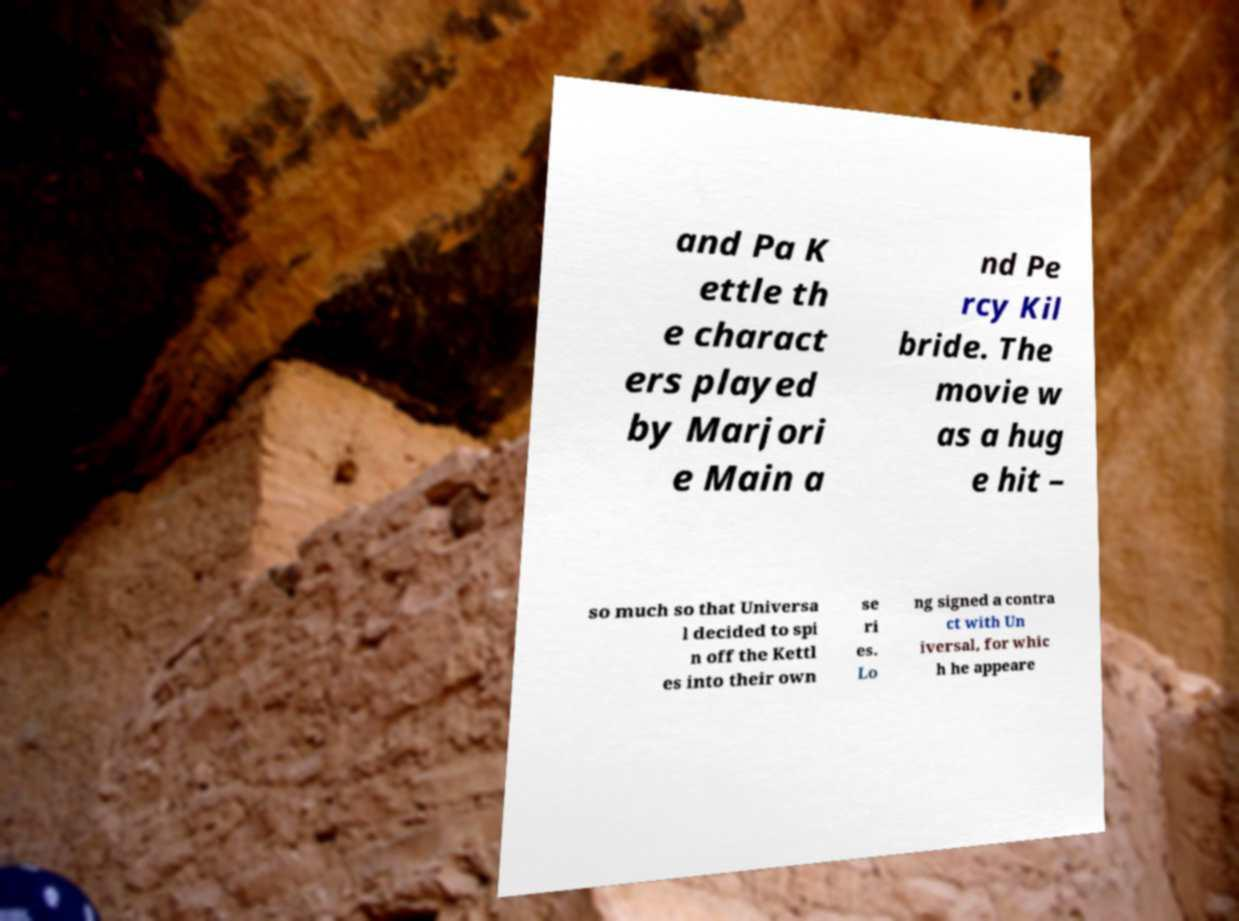What messages or text are displayed in this image? I need them in a readable, typed format. and Pa K ettle th e charact ers played by Marjori e Main a nd Pe rcy Kil bride. The movie w as a hug e hit – so much so that Universa l decided to spi n off the Kettl es into their own se ri es. Lo ng signed a contra ct with Un iversal, for whic h he appeare 